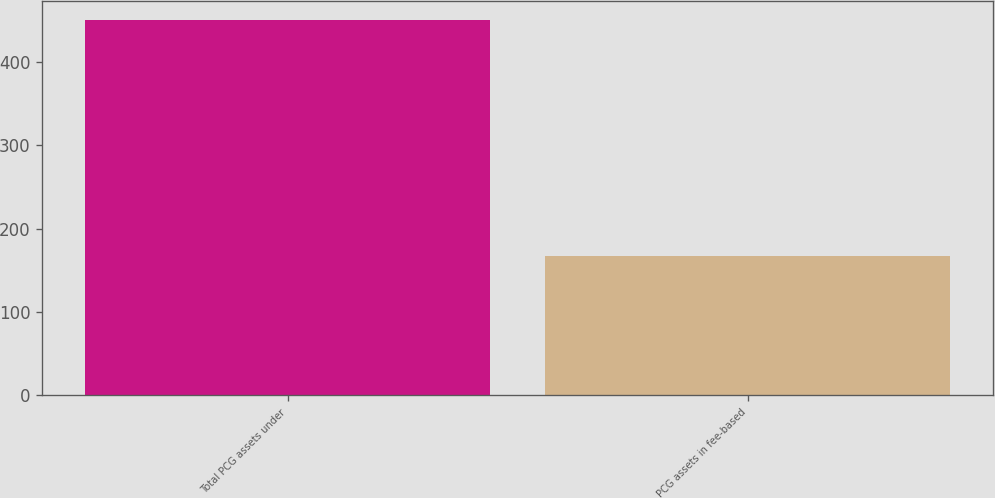<chart> <loc_0><loc_0><loc_500><loc_500><bar_chart><fcel>Total PCG assets under<fcel>PCG assets in fee-based<nl><fcel>450.6<fcel>167.7<nl></chart> 